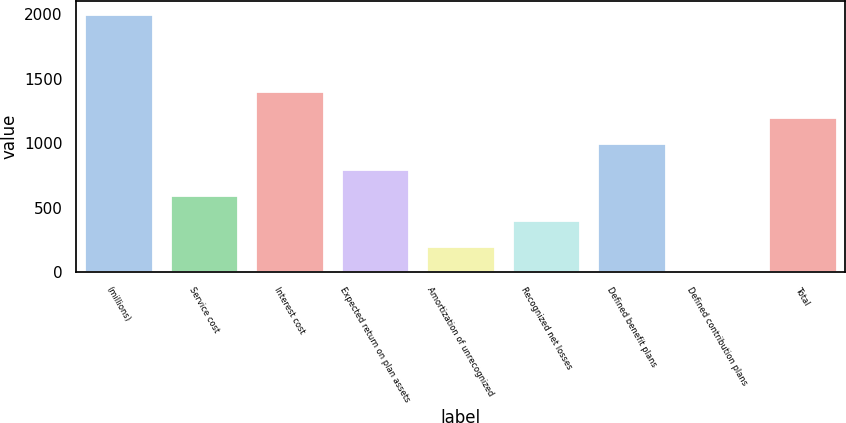Convert chart. <chart><loc_0><loc_0><loc_500><loc_500><bar_chart><fcel>(millions)<fcel>Service cost<fcel>Interest cost<fcel>Expected return on plan assets<fcel>Amortization of unrecognized<fcel>Recognized net losses<fcel>Defined benefit plans<fcel>Defined contribution plans<fcel>Total<nl><fcel>2003<fcel>601.81<fcel>1402.49<fcel>801.98<fcel>201.47<fcel>401.64<fcel>1002.15<fcel>1.3<fcel>1202.32<nl></chart> 